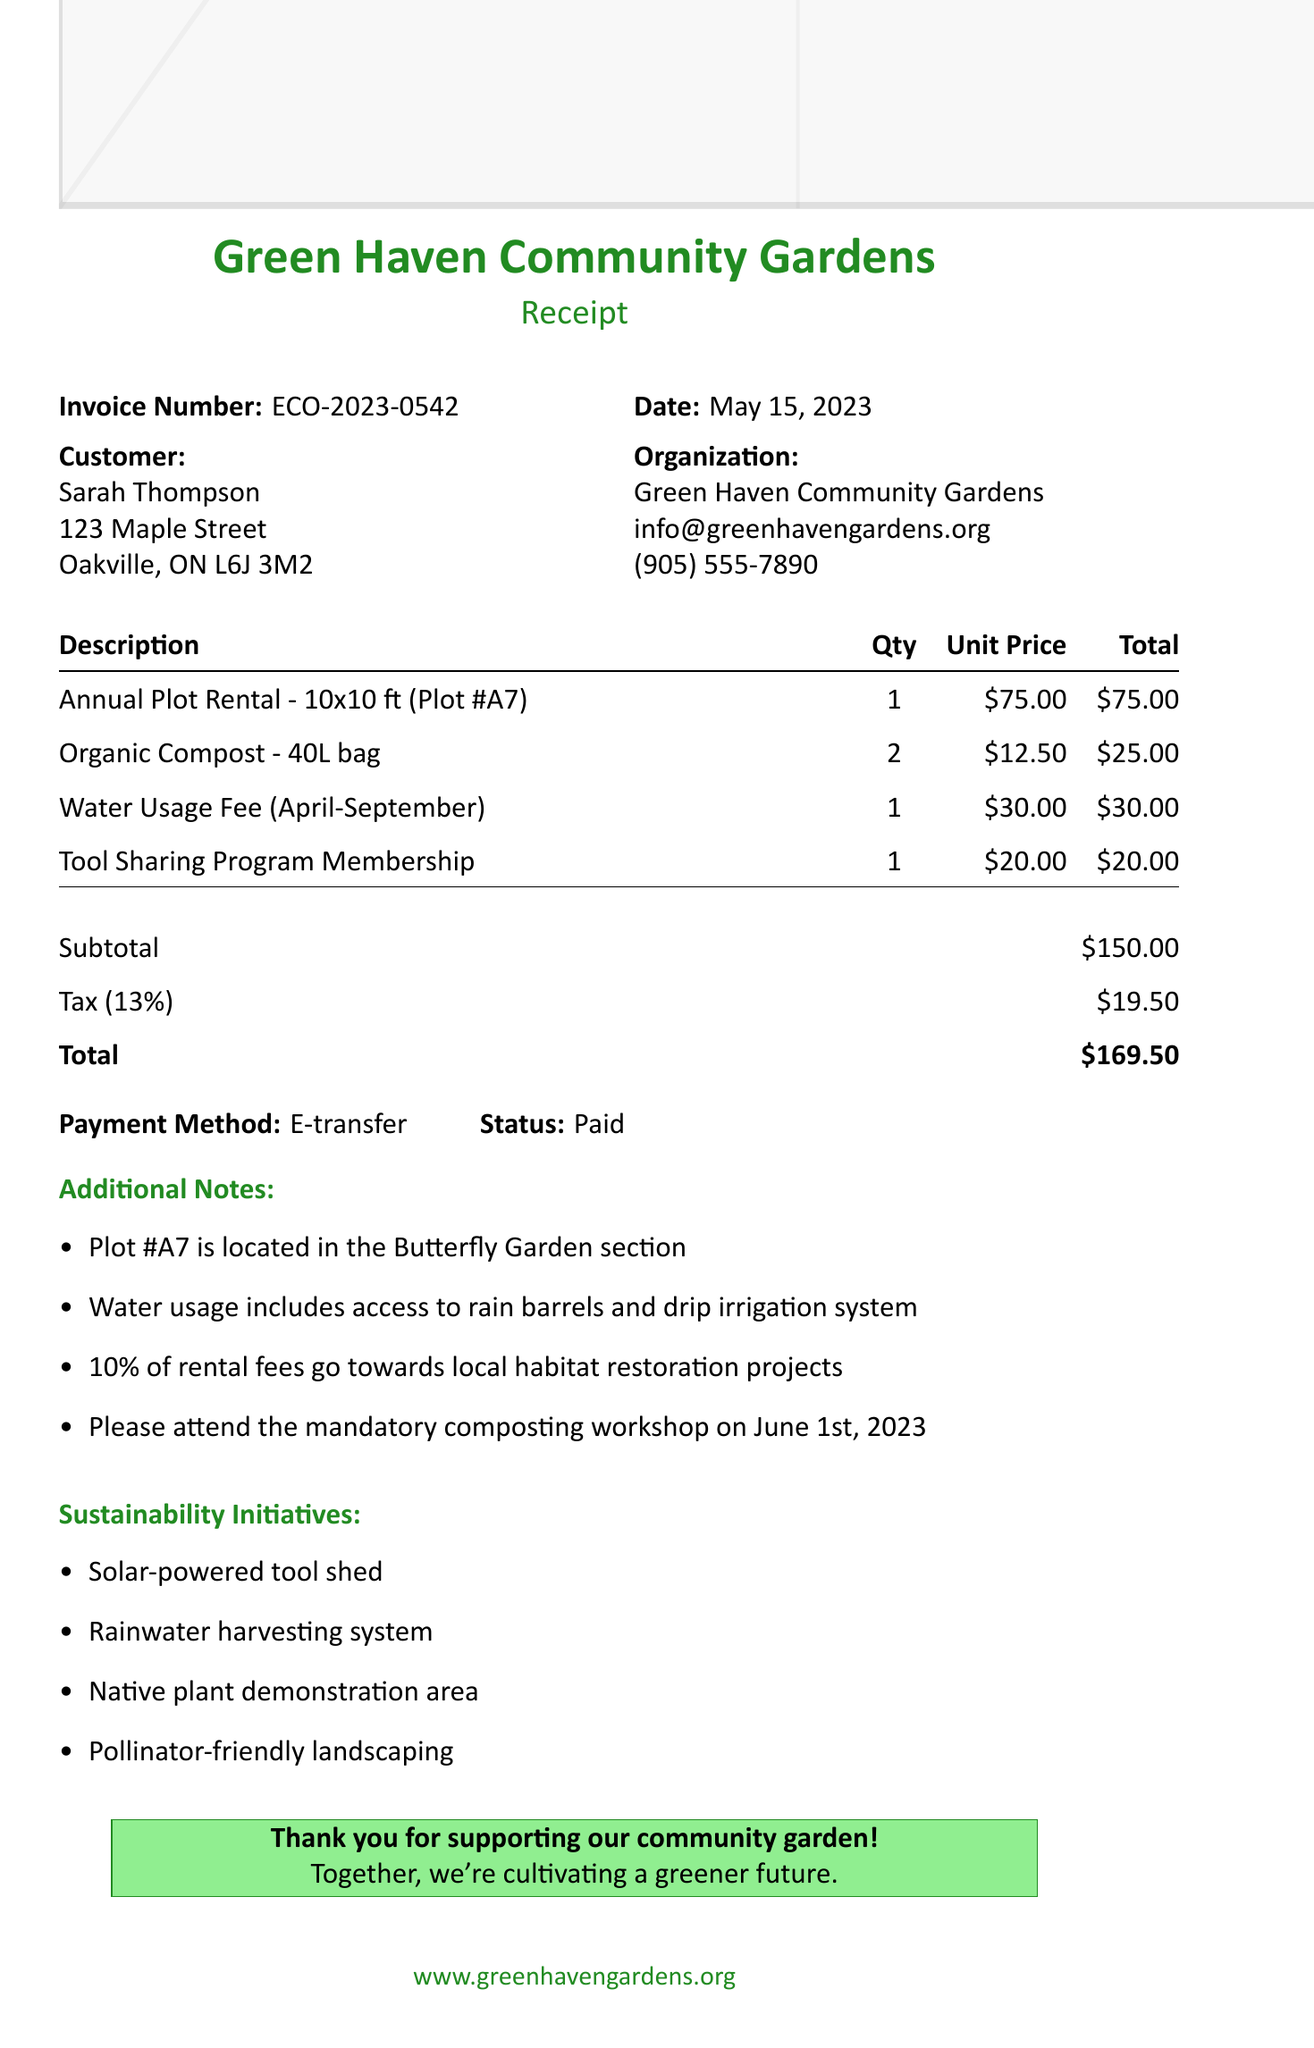What is the invoice number? The invoice number is specifically stated in the document and is a unique identifier for the receipt.
Answer: ECO-2023-0542 What is the total amount due? The total amount is calculated by adding the subtotal and tax. It is clearly indicated in the totals section.
Answer: $169.50 What was the quantity of organic compost bags rented? The quantity is provided in the itemized list of items rented and shows how many bags were acquired.
Answer: 2 What is the date of the invoice? The date is listed prominently at the top of the invoice and represents when the transaction occurred.
Answer: May 15, 2023 How much is the water usage fee? The water usage fee appears in the list of charges and specifies its cost for the designated period.
Answer: $30.00 What section is Plot #A7 located in? The document's additional notes section includes details about the location of the specific garden plot.
Answer: Butterfly Garden What percentage of rental fees goes to habitat restoration projects? The information related to the contribution of rental fees is mentioned in the additional notes, giving insight into financial support for ecological efforts.
Answer: 10% What method of payment was used? The payment method is explicitly stated in the payment status section of the document.
Answer: E-transfer What sustainability initiative features a water management system? One of the sustainability initiatives listed in the document directly mentions the management of water through its system.
Answer: Rainwater harvesting system 